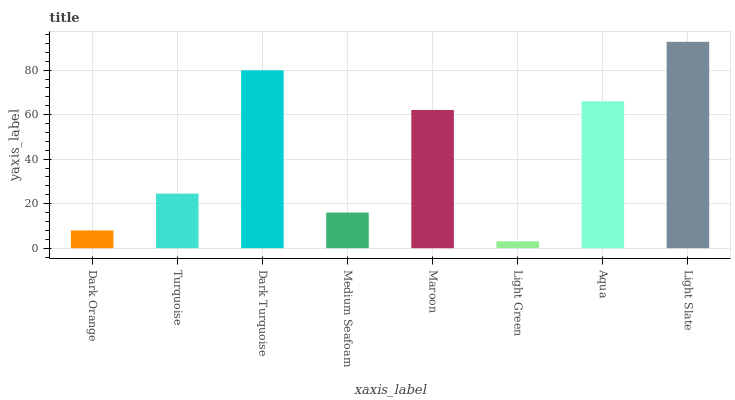Is Turquoise the minimum?
Answer yes or no. No. Is Turquoise the maximum?
Answer yes or no. No. Is Turquoise greater than Dark Orange?
Answer yes or no. Yes. Is Dark Orange less than Turquoise?
Answer yes or no. Yes. Is Dark Orange greater than Turquoise?
Answer yes or no. No. Is Turquoise less than Dark Orange?
Answer yes or no. No. Is Maroon the high median?
Answer yes or no. Yes. Is Turquoise the low median?
Answer yes or no. Yes. Is Medium Seafoam the high median?
Answer yes or no. No. Is Dark Orange the low median?
Answer yes or no. No. 